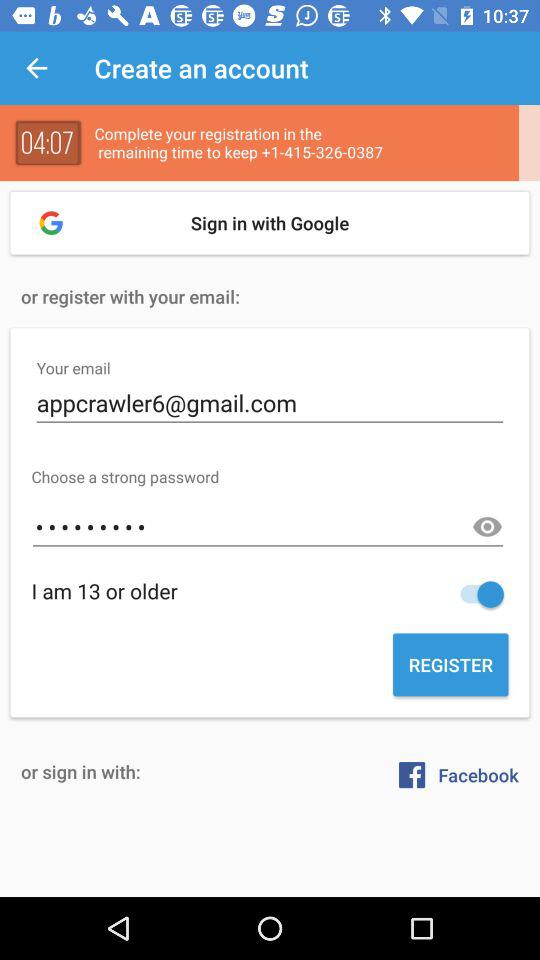What applications can be used to sign in to a profile? The application that can be used to sign to a profile is "Google". 